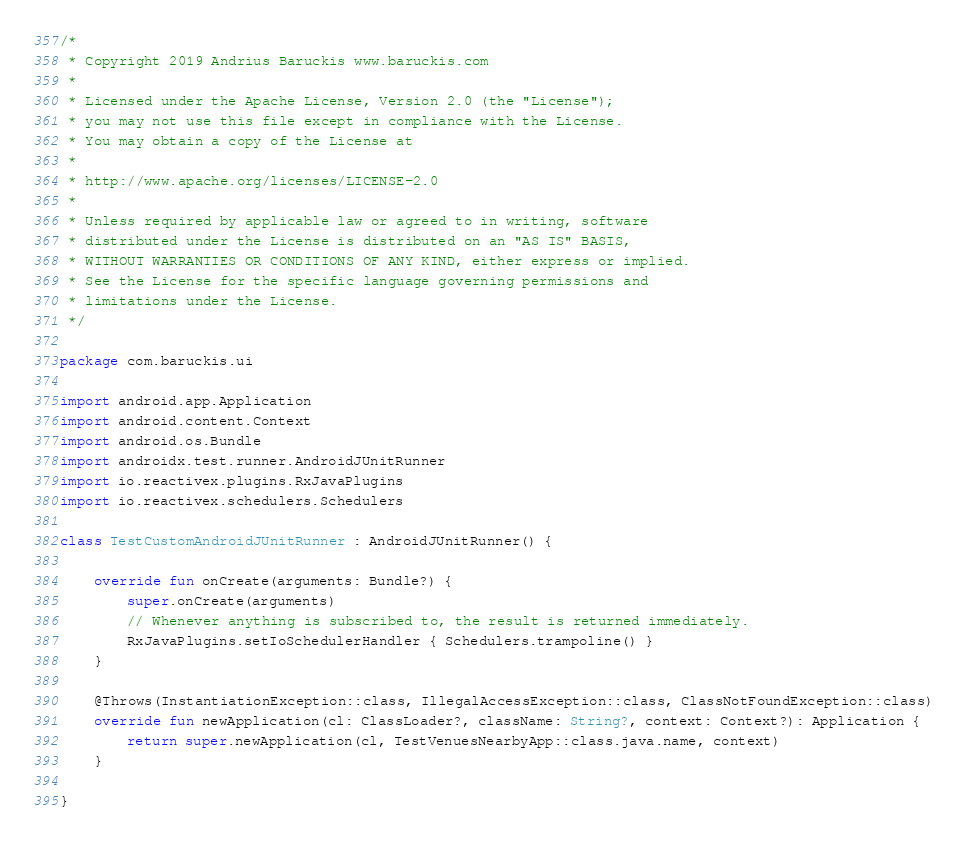<code> <loc_0><loc_0><loc_500><loc_500><_Kotlin_>/*
 * Copyright 2019 Andrius Baruckis www.baruckis.com
 *
 * Licensed under the Apache License, Version 2.0 (the "License");
 * you may not use this file except in compliance with the License.
 * You may obtain a copy of the License at
 *
 * http://www.apache.org/licenses/LICENSE-2.0
 *
 * Unless required by applicable law or agreed to in writing, software
 * distributed under the License is distributed on an "AS IS" BASIS,
 * WITHOUT WARRANTIES OR CONDITIONS OF ANY KIND, either express or implied.
 * See the License for the specific language governing permissions and
 * limitations under the License.
 */

package com.baruckis.ui

import android.app.Application
import android.content.Context
import android.os.Bundle
import androidx.test.runner.AndroidJUnitRunner
import io.reactivex.plugins.RxJavaPlugins
import io.reactivex.schedulers.Schedulers

class TestCustomAndroidJUnitRunner : AndroidJUnitRunner() {

    override fun onCreate(arguments: Bundle?) {
        super.onCreate(arguments)
        // Whenever anything is subscribed to, the result is returned immediately.
        RxJavaPlugins.setIoSchedulerHandler { Schedulers.trampoline() }
    }

    @Throws(InstantiationException::class, IllegalAccessException::class, ClassNotFoundException::class)
    override fun newApplication(cl: ClassLoader?, className: String?, context: Context?): Application {
        return super.newApplication(cl, TestVenuesNearbyApp::class.java.name, context)
    }

}</code> 